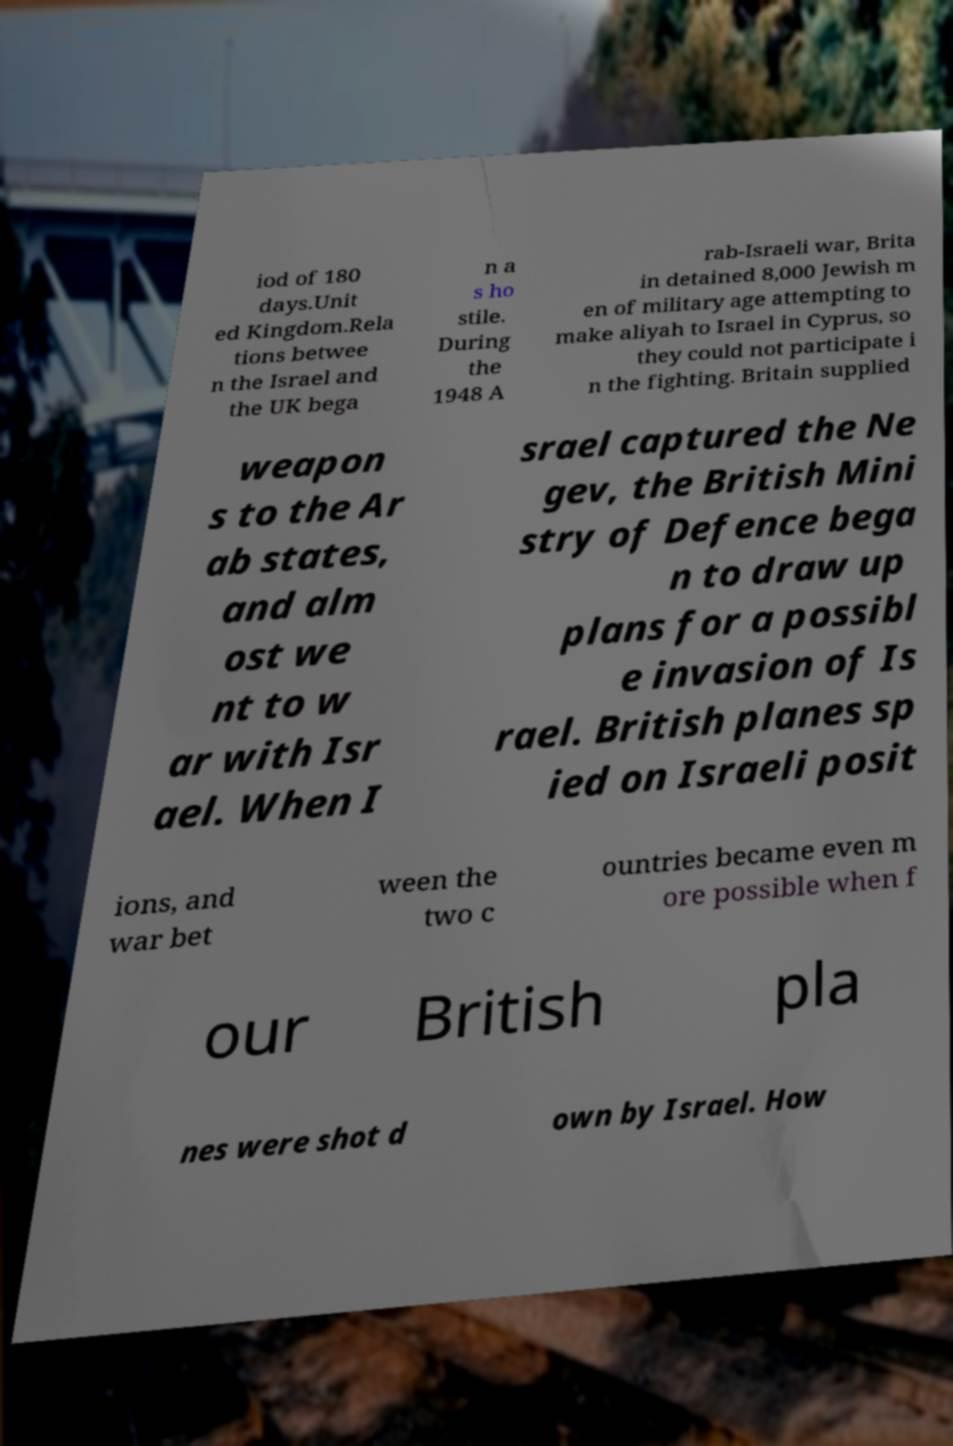Could you assist in decoding the text presented in this image and type it out clearly? iod of 180 days.Unit ed Kingdom.Rela tions betwee n the Israel and the UK bega n a s ho stile. During the 1948 A rab-Israeli war, Brita in detained 8,000 Jewish m en of military age attempting to make aliyah to Israel in Cyprus, so they could not participate i n the fighting. Britain supplied weapon s to the Ar ab states, and alm ost we nt to w ar with Isr ael. When I srael captured the Ne gev, the British Mini stry of Defence bega n to draw up plans for a possibl e invasion of Is rael. British planes sp ied on Israeli posit ions, and war bet ween the two c ountries became even m ore possible when f our British pla nes were shot d own by Israel. How 